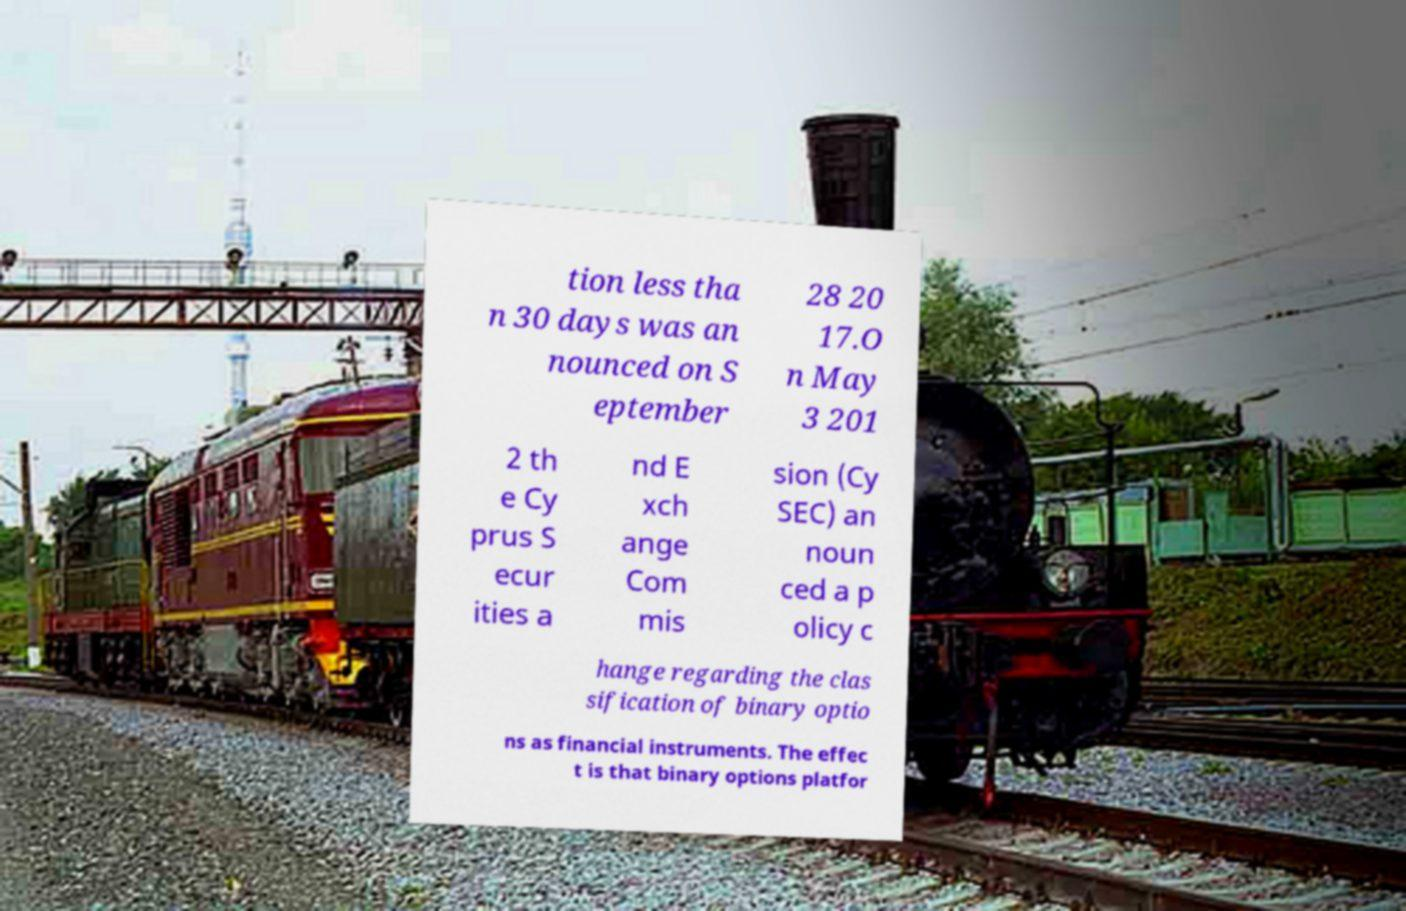Could you extract and type out the text from this image? tion less tha n 30 days was an nounced on S eptember 28 20 17.O n May 3 201 2 th e Cy prus S ecur ities a nd E xch ange Com mis sion (Cy SEC) an noun ced a p olicy c hange regarding the clas sification of binary optio ns as financial instruments. The effec t is that binary options platfor 